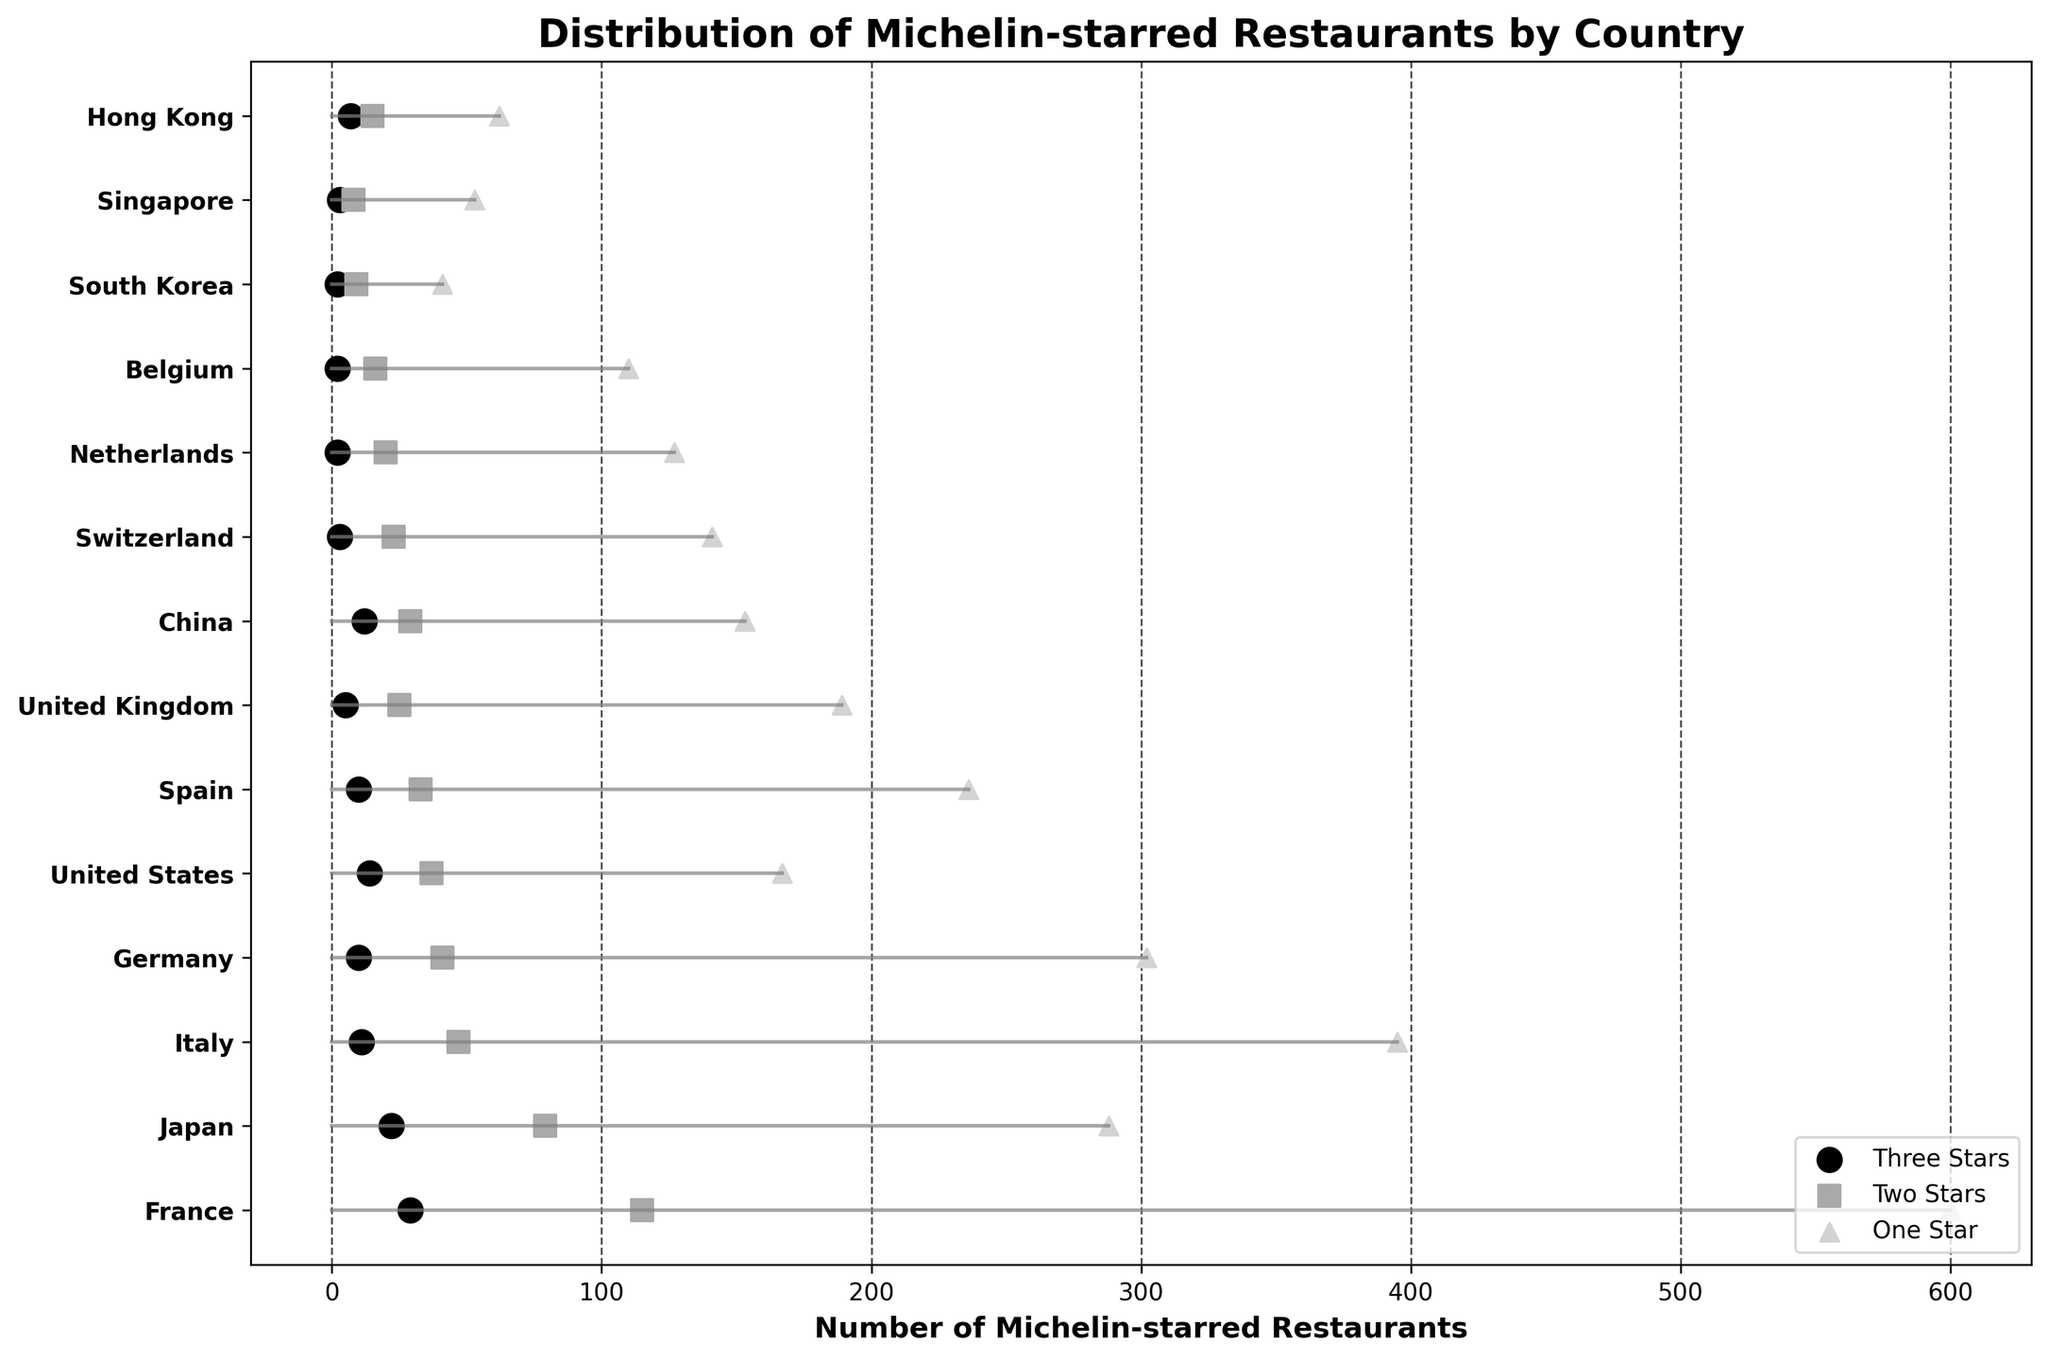What is the total number of Michelin-starred restaurants in France? The plot shows individual star categories for each country. To find the total, sum up the values for Three Stars, Two Stars, and One Star in France: 29 (Three Stars) + 86 (Two Stars) + 485 (One Star).
Answer: 600 Which country has the highest number of Three-Star restaurants? From the visual representation, France has the highest number of Three-Star restaurants, with 29 shown at the highest position on the Three-Star axis.
Answer: France How many more Two-Star restaurants does Japan have compared to China? From the figure, Japan has 57 Two-Star restaurants, and China has 17. The difference is 57 - 17.
Answer: 40 Which country has the least number of Michelin-starred restaurants in total? The country with the least total stars can be found by adding the numbers of Three Stars, Two Stars, and One Star for each country. South Korea has the fewest with 2 (Three Stars) + 7 (Two Stars) + 32 (One Star) = 41.
Answer: South Korea What is the total number of Michelin-starred restaurants in Asia? To find the total for Asian countries (Japan, China, South Korea, Singapore, Hong Kong), sum all their Michelin-starred restaurants: Japan (288) + China (153) + South Korea (41) + Singapore (53) + Hong Kong (62). The total is 288 + 153 + 41 + 53 + 62.
Answer: 597 How does the number of One-Star restaurants in Italy compare to that in Spain? From the figure, Italy has 348 One-Star restaurants, and Spain has 203. To compare, note that Italy has more One-Star restaurants than Spain.
Answer: Italy has more Are there any countries with an equal number of Three and Two-Star restaurants? The plot shows that both Hong Kong (7 and 8) and Singapore (3 and 5) have different values for Three and Two-Star restaurants. No countries have the same number.
Answer: No What is the total number of Two-Star restaurants across all countries? By looking at the figure, add the number of Two-Star restaurants for each country: 86 + 57 + 36 + 31 + 23 + 23 + 20 + 17 + 20 + 18 + 14 + 7 + 5 + 8.
Answer: 365 Which country in Europe has the most Michelin-starred restaurants overall? Analyze the total number of stars for European countries. France has the most with 600 in total, compared to other European countries.
Answer: France 